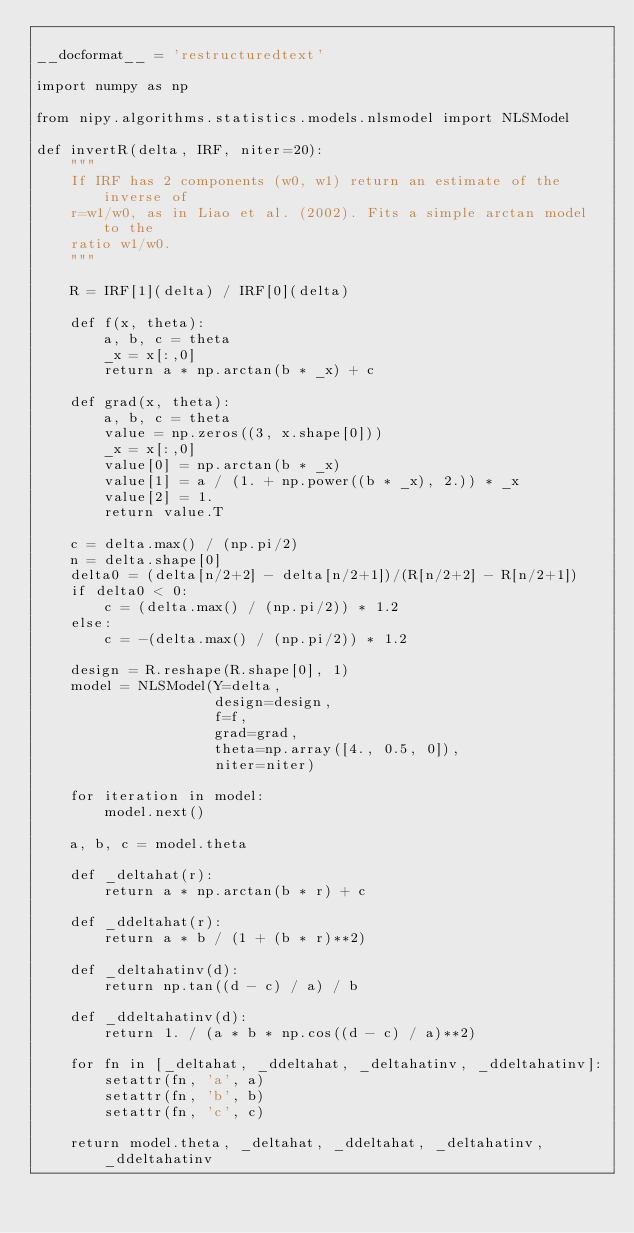<code> <loc_0><loc_0><loc_500><loc_500><_Python_>
__docformat__ = 'restructuredtext'

import numpy as np

from nipy.algorithms.statistics.models.nlsmodel import NLSModel

def invertR(delta, IRF, niter=20):
    """
    If IRF has 2 components (w0, w1) return an estimate of the inverse of
    r=w1/w0, as in Liao et al. (2002). Fits a simple arctan model to the
    ratio w1/w0.
    """

    R = IRF[1](delta) / IRF[0](delta)

    def f(x, theta):
        a, b, c = theta
        _x = x[:,0]
        return a * np.arctan(b * _x) + c

    def grad(x, theta):
        a, b, c = theta
        value = np.zeros((3, x.shape[0]))
        _x = x[:,0]
        value[0] = np.arctan(b * _x)
        value[1] = a / (1. + np.power((b * _x), 2.)) * _x
        value[2] = 1.
        return value.T

    c = delta.max() / (np.pi/2)
    n = delta.shape[0]
    delta0 = (delta[n/2+2] - delta[n/2+1])/(R[n/2+2] - R[n/2+1])
    if delta0 < 0:
        c = (delta.max() / (np.pi/2)) * 1.2
    else:
        c = -(delta.max() / (np.pi/2)) * 1.2

    design = R.reshape(R.shape[0], 1)
    model = NLSModel(Y=delta,
                     design=design,
                     f=f,
                     grad=grad,
                     theta=np.array([4., 0.5, 0]),
                     niter=niter)

    for iteration in model:
        model.next()

    a, b, c = model.theta

    def _deltahat(r):
        return a * np.arctan(b * r) + c

    def _ddeltahat(r):
        return a * b / (1 + (b * r)**2) 

    def _deltahatinv(d):
        return np.tan((d - c) / a) / b

    def _ddeltahatinv(d):
        return 1. / (a * b * np.cos((d - c) / a)**2)

    for fn in [_deltahat, _ddeltahat, _deltahatinv, _ddeltahatinv]:
        setattr(fn, 'a', a)
        setattr(fn, 'b', b)
        setattr(fn, 'c', c)

    return model.theta, _deltahat, _ddeltahat, _deltahatinv, _ddeltahatinv
</code> 